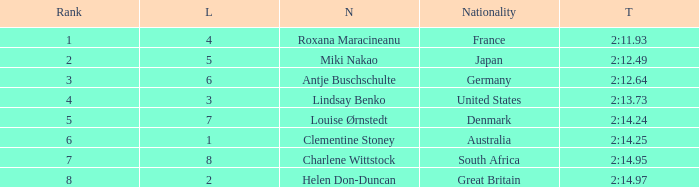What is the average Rank for a lane smaller than 3 with a nationality of Australia? 6.0. 